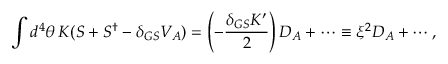Convert formula to latex. <formula><loc_0><loc_0><loc_500><loc_500>\int d ^ { 4 } \theta \, K ( S + S ^ { \dagger } - \delta _ { G S } V _ { A } ) = \left ( - \frac { \delta _ { G S } K ^ { \prime } } { 2 } \right ) D _ { A } + \cdots \equiv \xi ^ { 2 } D _ { A } + \cdots ,</formula> 